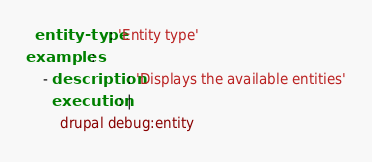Convert code to text. <code><loc_0><loc_0><loc_500><loc_500><_YAML_>  entity-type: 'Entity type'
examples:
    - description: 'Displays the available entities'
      execution: |
        drupal debug:entity
</code> 